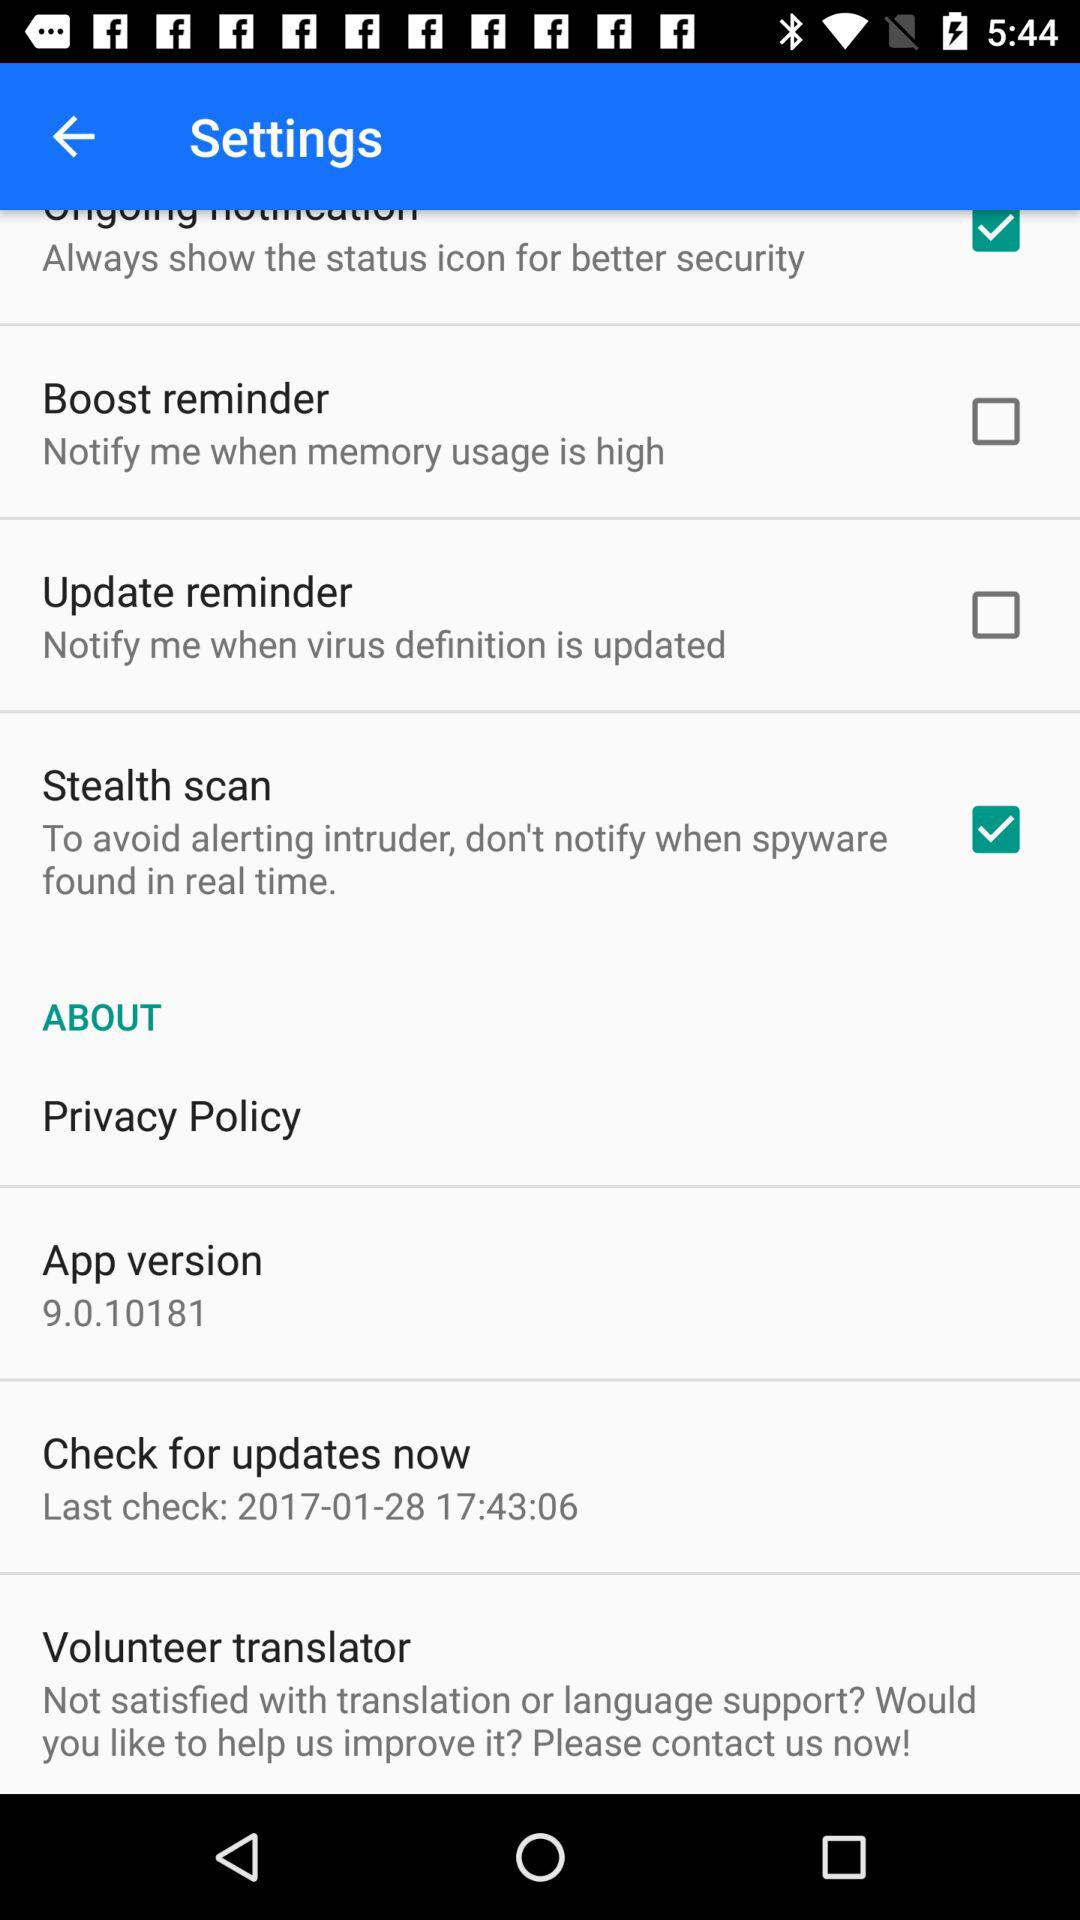Which is the version of the application? The version of the application is 9.0.10181. 